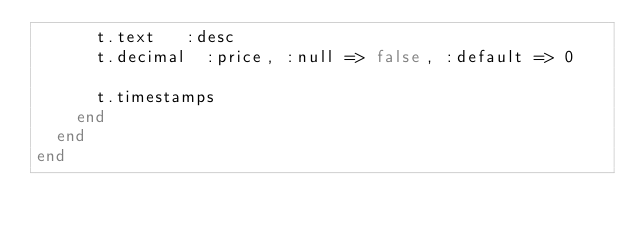<code> <loc_0><loc_0><loc_500><loc_500><_Ruby_>      t.text   :desc
      t.decimal  :price, :null => false, :default => 0
      
      t.timestamps
    end
  end
end
</code> 